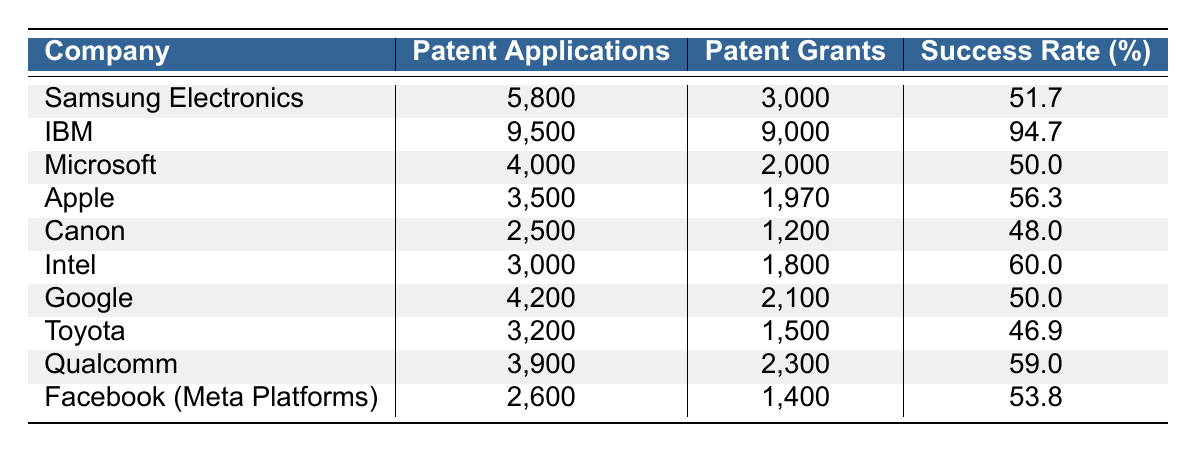What is the patent grant success rate for IBM? The table shows that IBM has 9,500 patent applications and 9,000 patent grants. The success rate can be calculated by dividing the number of grants by the number of applications and then multiplying by 100. Thus, the success rate is (9000 / 9500) * 100 = 94.7%.
Answer: 94.7% Which company received the least number of patent grants? By examining the "Patent Grants" column, Canon has the least with 1,200 grants compared to other companies.
Answer: Canon What is the total number of patent applications submitted by all companies listed? To find the total, add up the patent applications for all companies: 5800 + 9500 + 4000 + 3500 + 2500 + 3000 + 4200 + 3200 + 3900 + 2600 = 29,300.
Answer: 29300 Which company has the highest ratio of patent grants to applications? IBM has the highest success rate of 94.7%, which is calculated as (9000 / 9500) * 100. Other companies have lower success rates.
Answer: IBM Is it true that Samsung Electronics received more patents than Microsoft in 2021? Samsung Electronics received 3,000 patents while Microsoft received 2,000 patents. Therefore, it is true that Samsung received more patents than Microsoft.
Answer: Yes How many more patent applications did Google make compared to Facebook (Meta Platforms)? Google made 4,200 applications while Facebook made 2,600. The difference is 4200 - 2600 = 1,600 applications.
Answer: 1600 What is the average patent grant success rate for the listed companies? To find the average success rate, sum the individual success rates and divide by the total number of companies (10). (51.7 + 94.7 + 50.0 + 56.3 + 48.0 + 60.0 + 50.0 + 46.9 + 59.0 + 53.8) / 10 = 54.64.
Answer: 54.64 Which company has the highest number of patent applications? The maximum value in the "Patent Applications" column is 9,500 for IBM.
Answer: IBM How many companies had a success rate below 50%? From the success rates, Canon (48.0), Microsoft (50.0), and Toyota (46.9) had rates below 50%, which amounts to 3 companies.
Answer: 3 What is the total number of patent grants for companies with a success rate higher than 50%? The companies with a success rate higher than 50% are IBM (9,000), Intel (1,800), Qualcomm (2,300), and Apple (1,970). Their total grants are 9,000 + 1,800 + 2,300 + 1,970 = 15,070.
Answer: 15070 